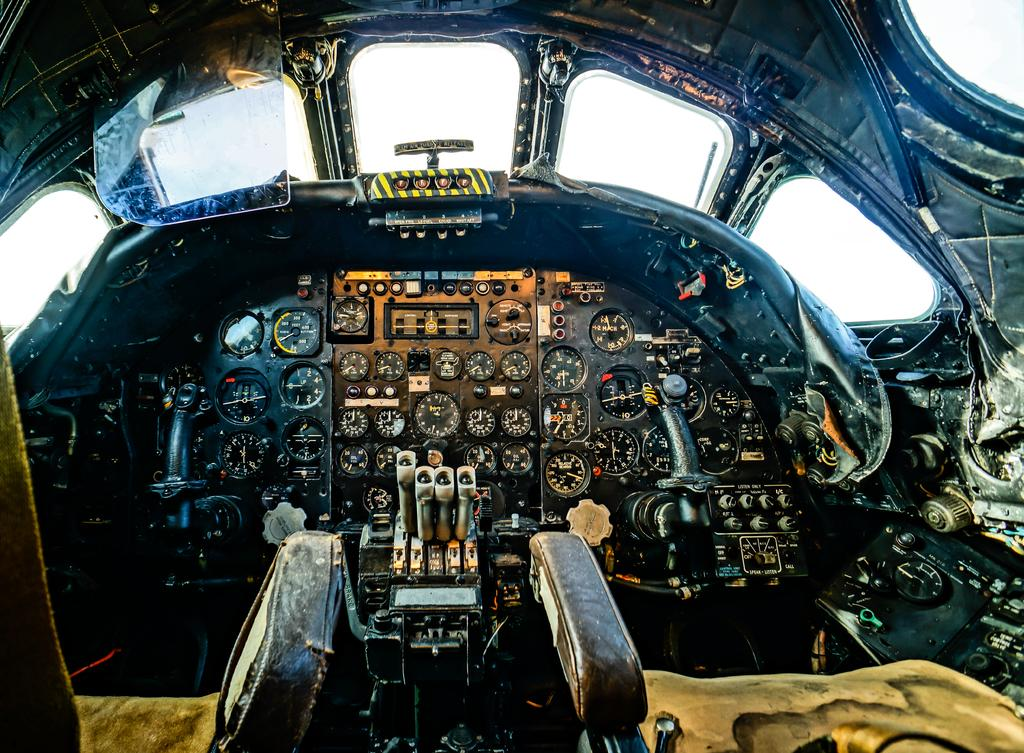What type of environment is depicted in the image? The image shows an inner view of a motor vehicle. What type of shade is covering the potato in the image? There is no potato or shade present in the image; it shows an inner view of a motor vehicle. 